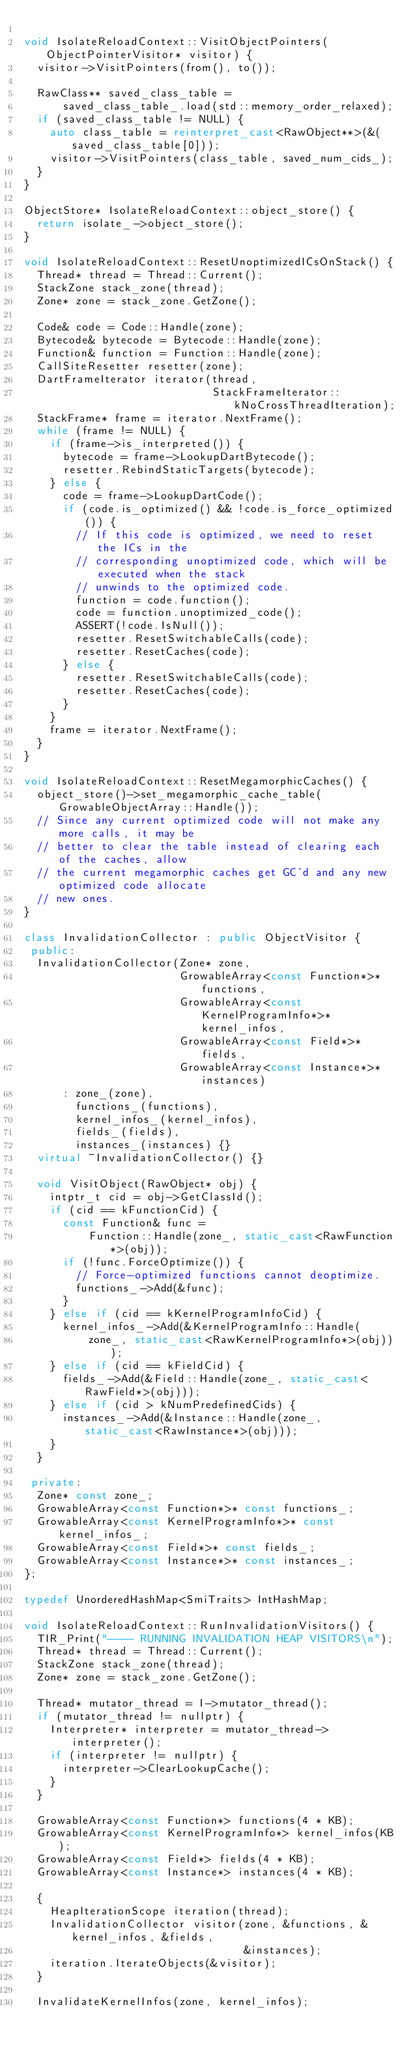<code> <loc_0><loc_0><loc_500><loc_500><_C++_>
void IsolateReloadContext::VisitObjectPointers(ObjectPointerVisitor* visitor) {
  visitor->VisitPointers(from(), to());

  RawClass** saved_class_table =
      saved_class_table_.load(std::memory_order_relaxed);
  if (saved_class_table != NULL) {
    auto class_table = reinterpret_cast<RawObject**>(&(saved_class_table[0]));
    visitor->VisitPointers(class_table, saved_num_cids_);
  }
}

ObjectStore* IsolateReloadContext::object_store() {
  return isolate_->object_store();
}

void IsolateReloadContext::ResetUnoptimizedICsOnStack() {
  Thread* thread = Thread::Current();
  StackZone stack_zone(thread);
  Zone* zone = stack_zone.GetZone();

  Code& code = Code::Handle(zone);
  Bytecode& bytecode = Bytecode::Handle(zone);
  Function& function = Function::Handle(zone);
  CallSiteResetter resetter(zone);
  DartFrameIterator iterator(thread,
                             StackFrameIterator::kNoCrossThreadIteration);
  StackFrame* frame = iterator.NextFrame();
  while (frame != NULL) {
    if (frame->is_interpreted()) {
      bytecode = frame->LookupDartBytecode();
      resetter.RebindStaticTargets(bytecode);
    } else {
      code = frame->LookupDartCode();
      if (code.is_optimized() && !code.is_force_optimized()) {
        // If this code is optimized, we need to reset the ICs in the
        // corresponding unoptimized code, which will be executed when the stack
        // unwinds to the optimized code.
        function = code.function();
        code = function.unoptimized_code();
        ASSERT(!code.IsNull());
        resetter.ResetSwitchableCalls(code);
        resetter.ResetCaches(code);
      } else {
        resetter.ResetSwitchableCalls(code);
        resetter.ResetCaches(code);
      }
    }
    frame = iterator.NextFrame();
  }
}

void IsolateReloadContext::ResetMegamorphicCaches() {
  object_store()->set_megamorphic_cache_table(GrowableObjectArray::Handle());
  // Since any current optimized code will not make any more calls, it may be
  // better to clear the table instead of clearing each of the caches, allow
  // the current megamorphic caches get GC'd and any new optimized code allocate
  // new ones.
}

class InvalidationCollector : public ObjectVisitor {
 public:
  InvalidationCollector(Zone* zone,
                        GrowableArray<const Function*>* functions,
                        GrowableArray<const KernelProgramInfo*>* kernel_infos,
                        GrowableArray<const Field*>* fields,
                        GrowableArray<const Instance*>* instances)
      : zone_(zone),
        functions_(functions),
        kernel_infos_(kernel_infos),
        fields_(fields),
        instances_(instances) {}
  virtual ~InvalidationCollector() {}

  void VisitObject(RawObject* obj) {
    intptr_t cid = obj->GetClassId();
    if (cid == kFunctionCid) {
      const Function& func =
          Function::Handle(zone_, static_cast<RawFunction*>(obj));
      if (!func.ForceOptimize()) {
        // Force-optimized functions cannot deoptimize.
        functions_->Add(&func);
      }
    } else if (cid == kKernelProgramInfoCid) {
      kernel_infos_->Add(&KernelProgramInfo::Handle(
          zone_, static_cast<RawKernelProgramInfo*>(obj)));
    } else if (cid == kFieldCid) {
      fields_->Add(&Field::Handle(zone_, static_cast<RawField*>(obj)));
    } else if (cid > kNumPredefinedCids) {
      instances_->Add(&Instance::Handle(zone_, static_cast<RawInstance*>(obj)));
    }
  }

 private:
  Zone* const zone_;
  GrowableArray<const Function*>* const functions_;
  GrowableArray<const KernelProgramInfo*>* const kernel_infos_;
  GrowableArray<const Field*>* const fields_;
  GrowableArray<const Instance*>* const instances_;
};

typedef UnorderedHashMap<SmiTraits> IntHashMap;

void IsolateReloadContext::RunInvalidationVisitors() {
  TIR_Print("---- RUNNING INVALIDATION HEAP VISITORS\n");
  Thread* thread = Thread::Current();
  StackZone stack_zone(thread);
  Zone* zone = stack_zone.GetZone();

  Thread* mutator_thread = I->mutator_thread();
  if (mutator_thread != nullptr) {
    Interpreter* interpreter = mutator_thread->interpreter();
    if (interpreter != nullptr) {
      interpreter->ClearLookupCache();
    }
  }

  GrowableArray<const Function*> functions(4 * KB);
  GrowableArray<const KernelProgramInfo*> kernel_infos(KB);
  GrowableArray<const Field*> fields(4 * KB);
  GrowableArray<const Instance*> instances(4 * KB);

  {
    HeapIterationScope iteration(thread);
    InvalidationCollector visitor(zone, &functions, &kernel_infos, &fields,
                                  &instances);
    iteration.IterateObjects(&visitor);
  }

  InvalidateKernelInfos(zone, kernel_infos);</code> 